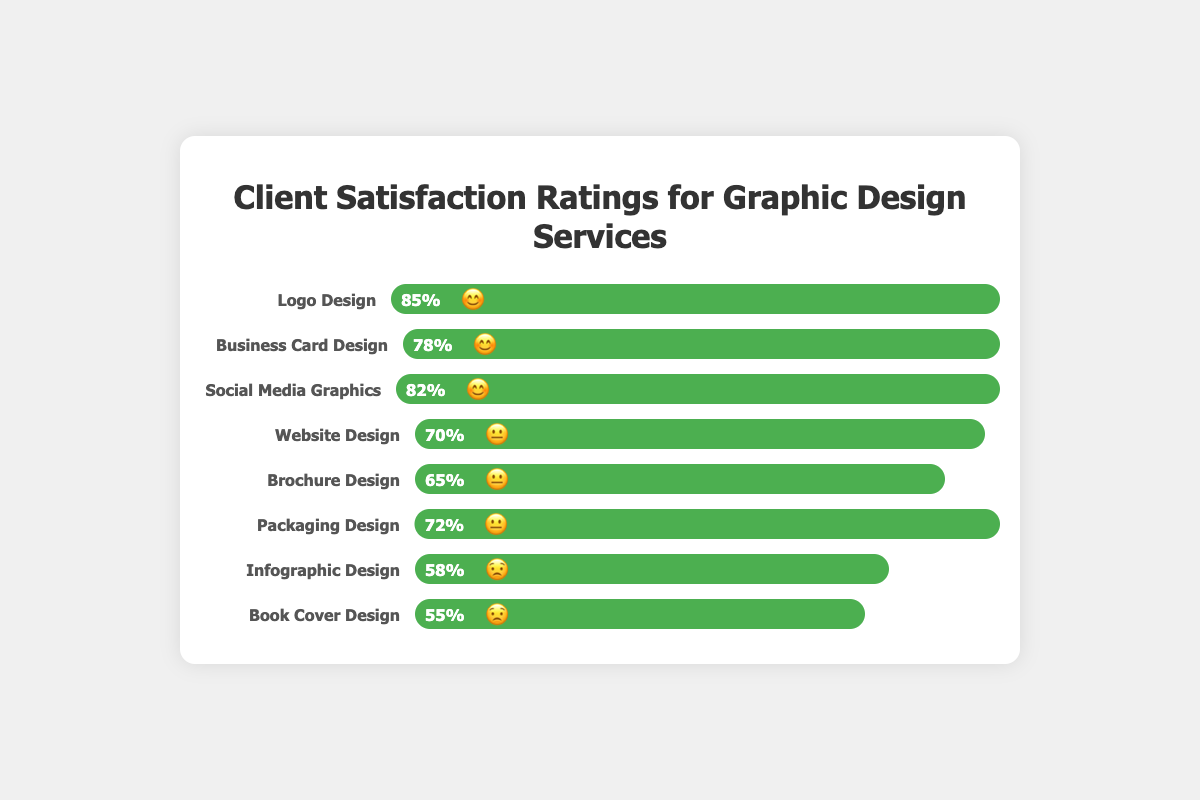how many types of graphic design services are shown in the figure? The figure displays a list of different graphic design services. By counting the items listed, we can determine the total number of graphic design services represented.
Answer: 8 Which service has the highest client satisfaction rating? We need to identify the service with the highest percentage and an emoji of 😊. Look for the highest value in the percentage columns next to the 😊 emoji. The highest percentage is 85% for Logo Design.
Answer: Logo Design What is the difference in satisfaction percentages between Business Card Design and Website Design? We need to subtract the percentage of Website Design (70%) from the percentage of Business Card Design (78%). 78% - 70% = 8%
Answer: 8% Which services have a satisfaction rating that is greater than 75%? We need to list the services with percentages higher than 75%. These services are Logo Design (85%), Business Card Design (78%), and Social Media Graphics (82%).
Answer: Logo Design, Business Card Design, Social Media Graphics What is the average satisfaction rating for services marked with the "😟" emoji? We need to find the average of the percentages for services marked with the 😟 emoji. The services are Infographic Design (58%) and Book Cover Design (55%). We sum these and divide by the number of services: (58 + 55) / 2 = 113 / 2 = 56.5%
Answer: 56.5% How many services have a satisfaction rating less than 60%? We need to count the services with satisfaction percentages under 60%. The services meeting this criterion are Infographic Design (58%) and Book Cover Design (55%). Therefore, there are 2 services.
Answer: 2 Which services have a 😐 satisfaction rating? We need to list the services labeled with the 😐 emoji. These services are Website Design (70%), Brochure Design (65%), and Packaging Design (72%).
Answer: Website Design, Brochure Design, Packaging Design What is the range of satisfaction percentages for the services? The range is calculated by subtracting the smallest percentage from the largest percentage. The highest percentage is 85% (Logo Design) and the lowest is 55% (Book Cover Design). So, 85% - 55% = 30%.
Answer: 30% 